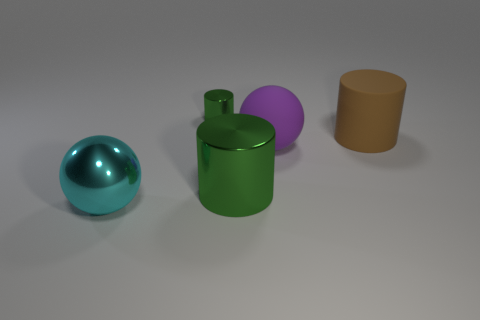There is a tiny green thing; does it have the same shape as the big metal object right of the cyan metal thing?
Keep it short and to the point. Yes. Are there any tiny cylinders that have the same color as the big rubber cylinder?
Provide a succinct answer. No. What number of balls are purple rubber things or large rubber objects?
Provide a short and direct response. 1. Are there any other tiny shiny objects that have the same shape as the tiny green thing?
Give a very brief answer. No. How many other things are the same color as the small thing?
Offer a terse response. 1. Are there fewer purple balls to the left of the cyan metal sphere than brown things?
Keep it short and to the point. Yes. What number of brown rubber objects are there?
Ensure brevity in your answer.  1. What number of big blue objects are made of the same material as the tiny object?
Keep it short and to the point. 0. What number of things are either metal things that are right of the shiny ball or big metal balls?
Make the answer very short. 3. Is the number of large cylinders that are to the right of the brown thing less than the number of large brown rubber cylinders behind the tiny object?
Ensure brevity in your answer.  No. 